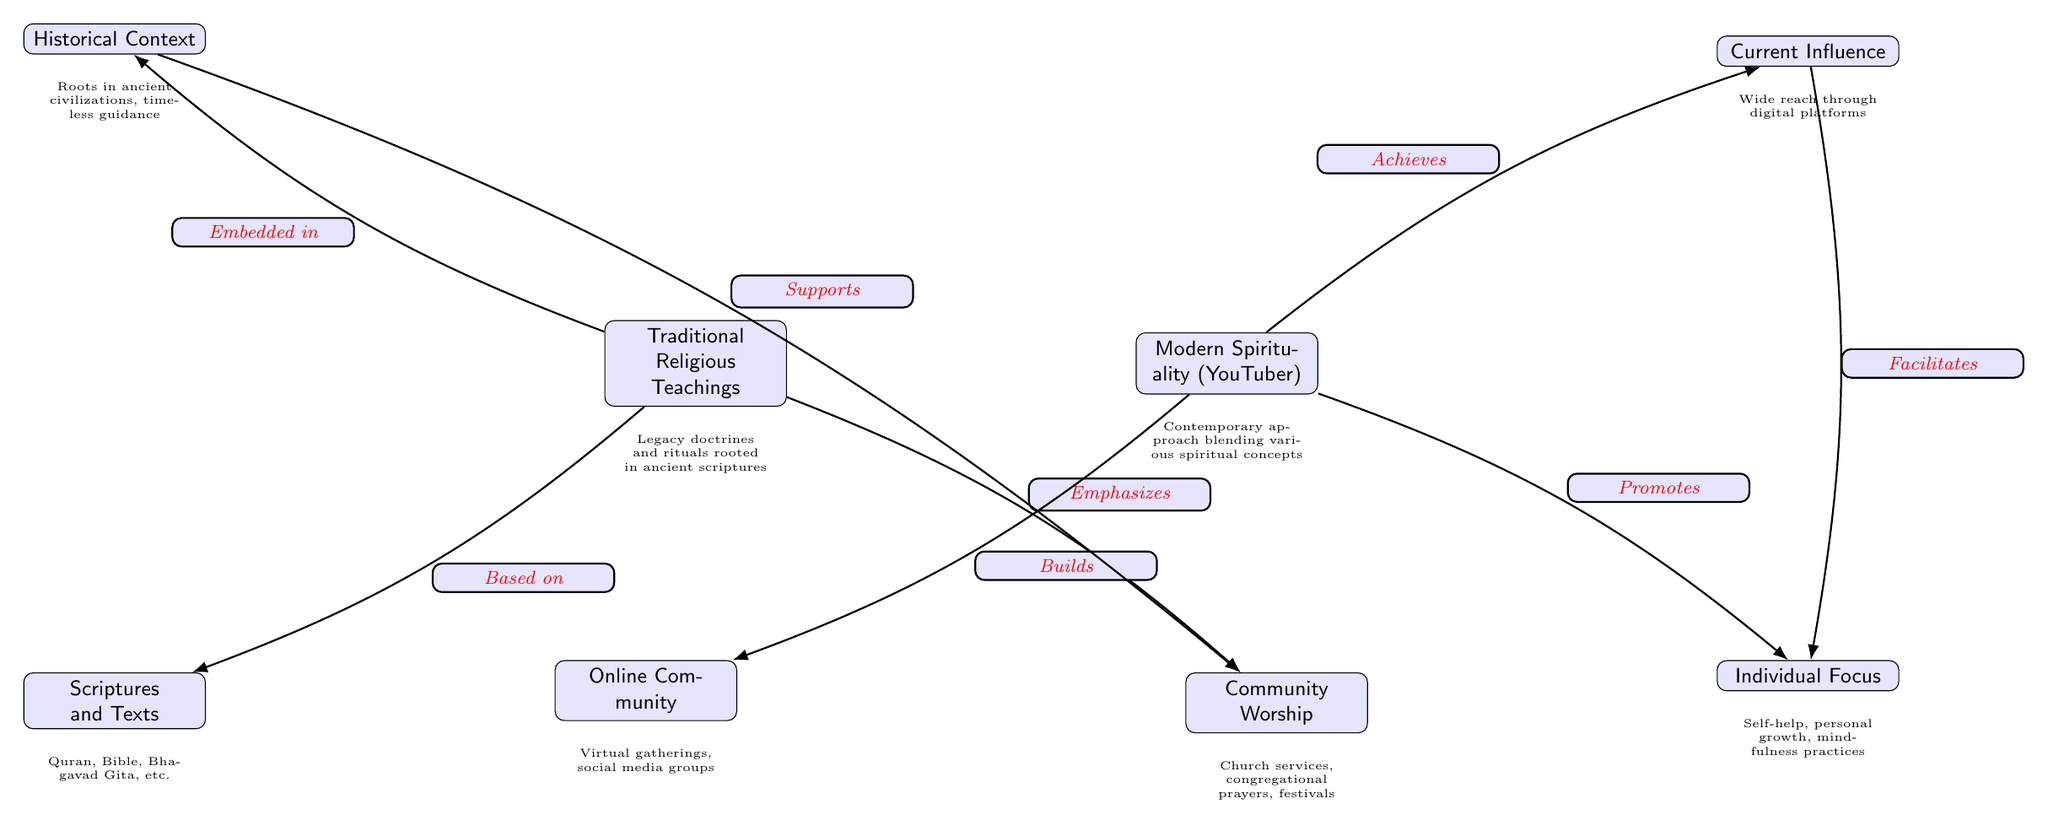What does Traditional Religious Teachings emphasize? In the diagram, you can see an edge pointing from Traditional Religious Teachings to Community Worship, with the label "Emphasizes." This indicates that Community Worship is a key aspect of Traditional Religious Teachings.
Answer: Community Worship What supports Community Worship? By following the arrows backward from Community Worship, you'll notice it points to Historical Context, indicating that Historical Context provides support for Community Worship.
Answer: Historical Context How many nodes are in the diagram? The diagram includes eight nodes as indicated by the various boxes representing distinct categories such as Traditional Religious Teachings, Modern Spirituality, and their subcomponents.
Answer: 8 What does Modern Spirituality promote? The flow of the diagram shows an edge from Modern Spirituality to Individual Focus labeled "Promotes," suggesting that Individual Focus is a significant aspect of Modern Spirituality.
Answer: Individual Focus Which two nodes connect through the edge labeled "Facilitates"? The connection labeled "Facilitates" goes from Current Influence to Individual Focus in the diagram, indicating that Current Influence plays a role in facilitating Individual Focus in modern spirituality.
Answer: Current Influence and Individual Focus What is embedded in Traditional Religious Teachings? From the diagram, there is a direct connection from Traditional Religious Teachings to Historical Context, marked by the label "Embedded in," which implies that Traditional Religious Teachings are deeply connected to Historical Context.
Answer: Historical Context What does Modern Spirituality achieve? The diagram shows an edge leading from Modern Spirituality to Current Influence marked "Achieves," suggesting that Current Influence is a result or outcome of Modern Spirituality.
Answer: Current Influence What type of community does Modern Spirituality build? According to the diagram, Modern Spirituality is connected to Online Community through the edge marked "Builds," indicating that a key feature of Modern Spirituality is the creation of an Online Community.
Answer: Online Community 